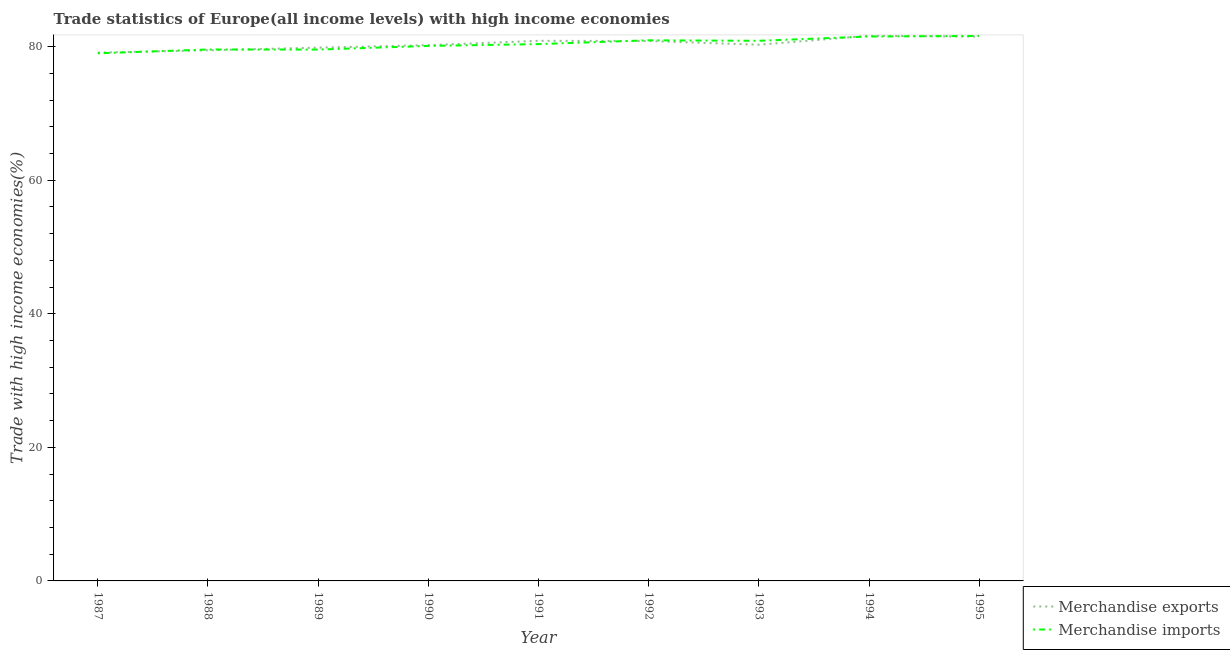How many different coloured lines are there?
Ensure brevity in your answer.  2. Does the line corresponding to merchandise exports intersect with the line corresponding to merchandise imports?
Offer a terse response. Yes. What is the merchandise exports in 1993?
Your response must be concise. 80.3. Across all years, what is the maximum merchandise exports?
Offer a terse response. 81.64. Across all years, what is the minimum merchandise imports?
Your answer should be very brief. 79.01. In which year was the merchandise exports maximum?
Provide a succinct answer. 1994. In which year was the merchandise imports minimum?
Your response must be concise. 1987. What is the total merchandise imports in the graph?
Your answer should be compact. 723.65. What is the difference between the merchandise imports in 1988 and that in 1991?
Your answer should be very brief. -0.81. What is the difference between the merchandise exports in 1992 and the merchandise imports in 1988?
Your answer should be very brief. 1.27. What is the average merchandise imports per year?
Provide a succinct answer. 80.41. In the year 1987, what is the difference between the merchandise exports and merchandise imports?
Provide a short and direct response. 0.1. In how many years, is the merchandise imports greater than 16 %?
Keep it short and to the point. 9. What is the ratio of the merchandise imports in 1988 to that in 1993?
Your answer should be very brief. 0.98. Is the merchandise exports in 1992 less than that in 1993?
Offer a terse response. No. Is the difference between the merchandise exports in 1992 and 1994 greater than the difference between the merchandise imports in 1992 and 1994?
Offer a terse response. No. What is the difference between the highest and the second highest merchandise exports?
Your answer should be very brief. 0.13. What is the difference between the highest and the lowest merchandise exports?
Provide a succinct answer. 2.53. In how many years, is the merchandise exports greater than the average merchandise exports taken over all years?
Your answer should be compact. 4. Is the sum of the merchandise imports in 1988 and 1990 greater than the maximum merchandise exports across all years?
Keep it short and to the point. Yes. Does the merchandise imports monotonically increase over the years?
Offer a terse response. No. How many lines are there?
Offer a very short reply. 2. What is the difference between two consecutive major ticks on the Y-axis?
Provide a short and direct response. 20. Are the values on the major ticks of Y-axis written in scientific E-notation?
Keep it short and to the point. No. Where does the legend appear in the graph?
Your answer should be very brief. Bottom right. What is the title of the graph?
Make the answer very short. Trade statistics of Europe(all income levels) with high income economies. Does "Forest land" appear as one of the legend labels in the graph?
Your answer should be compact. No. What is the label or title of the Y-axis?
Your response must be concise. Trade with high income economies(%). What is the Trade with high income economies(%) of Merchandise exports in 1987?
Your answer should be very brief. 79.11. What is the Trade with high income economies(%) of Merchandise imports in 1987?
Keep it short and to the point. 79.01. What is the Trade with high income economies(%) in Merchandise exports in 1988?
Your response must be concise. 79.46. What is the Trade with high income economies(%) in Merchandise imports in 1988?
Your answer should be very brief. 79.58. What is the Trade with high income economies(%) in Merchandise exports in 1989?
Keep it short and to the point. 79.86. What is the Trade with high income economies(%) in Merchandise imports in 1989?
Ensure brevity in your answer.  79.57. What is the Trade with high income economies(%) of Merchandise exports in 1990?
Your answer should be compact. 80.23. What is the Trade with high income economies(%) in Merchandise imports in 1990?
Your answer should be compact. 80.12. What is the Trade with high income economies(%) in Merchandise exports in 1991?
Your answer should be very brief. 80.88. What is the Trade with high income economies(%) of Merchandise imports in 1991?
Ensure brevity in your answer.  80.39. What is the Trade with high income economies(%) in Merchandise exports in 1992?
Give a very brief answer. 80.85. What is the Trade with high income economies(%) in Merchandise imports in 1992?
Offer a very short reply. 80.96. What is the Trade with high income economies(%) of Merchandise exports in 1993?
Provide a short and direct response. 80.3. What is the Trade with high income economies(%) of Merchandise imports in 1993?
Provide a succinct answer. 80.88. What is the Trade with high income economies(%) in Merchandise exports in 1994?
Provide a short and direct response. 81.64. What is the Trade with high income economies(%) of Merchandise imports in 1994?
Make the answer very short. 81.53. What is the Trade with high income economies(%) of Merchandise exports in 1995?
Your response must be concise. 81.51. What is the Trade with high income economies(%) in Merchandise imports in 1995?
Keep it short and to the point. 81.61. Across all years, what is the maximum Trade with high income economies(%) in Merchandise exports?
Give a very brief answer. 81.64. Across all years, what is the maximum Trade with high income economies(%) in Merchandise imports?
Offer a terse response. 81.61. Across all years, what is the minimum Trade with high income economies(%) of Merchandise exports?
Your answer should be very brief. 79.11. Across all years, what is the minimum Trade with high income economies(%) of Merchandise imports?
Give a very brief answer. 79.01. What is the total Trade with high income economies(%) in Merchandise exports in the graph?
Your answer should be compact. 723.84. What is the total Trade with high income economies(%) of Merchandise imports in the graph?
Give a very brief answer. 723.65. What is the difference between the Trade with high income economies(%) of Merchandise exports in 1987 and that in 1988?
Ensure brevity in your answer.  -0.35. What is the difference between the Trade with high income economies(%) of Merchandise imports in 1987 and that in 1988?
Provide a succinct answer. -0.56. What is the difference between the Trade with high income economies(%) in Merchandise exports in 1987 and that in 1989?
Your answer should be very brief. -0.75. What is the difference between the Trade with high income economies(%) of Merchandise imports in 1987 and that in 1989?
Your response must be concise. -0.56. What is the difference between the Trade with high income economies(%) in Merchandise exports in 1987 and that in 1990?
Your answer should be compact. -1.12. What is the difference between the Trade with high income economies(%) of Merchandise imports in 1987 and that in 1990?
Give a very brief answer. -1.1. What is the difference between the Trade with high income economies(%) of Merchandise exports in 1987 and that in 1991?
Provide a short and direct response. -1.77. What is the difference between the Trade with high income economies(%) of Merchandise imports in 1987 and that in 1991?
Provide a succinct answer. -1.38. What is the difference between the Trade with high income economies(%) of Merchandise exports in 1987 and that in 1992?
Offer a terse response. -1.74. What is the difference between the Trade with high income economies(%) of Merchandise imports in 1987 and that in 1992?
Make the answer very short. -1.95. What is the difference between the Trade with high income economies(%) of Merchandise exports in 1987 and that in 1993?
Provide a short and direct response. -1.18. What is the difference between the Trade with high income economies(%) in Merchandise imports in 1987 and that in 1993?
Make the answer very short. -1.87. What is the difference between the Trade with high income economies(%) of Merchandise exports in 1987 and that in 1994?
Your response must be concise. -2.53. What is the difference between the Trade with high income economies(%) in Merchandise imports in 1987 and that in 1994?
Your response must be concise. -2.51. What is the difference between the Trade with high income economies(%) of Merchandise exports in 1987 and that in 1995?
Your response must be concise. -2.39. What is the difference between the Trade with high income economies(%) of Merchandise imports in 1987 and that in 1995?
Keep it short and to the point. -2.6. What is the difference between the Trade with high income economies(%) in Merchandise exports in 1988 and that in 1989?
Give a very brief answer. -0.39. What is the difference between the Trade with high income economies(%) of Merchandise imports in 1988 and that in 1989?
Provide a succinct answer. 0.01. What is the difference between the Trade with high income economies(%) in Merchandise exports in 1988 and that in 1990?
Your answer should be very brief. -0.77. What is the difference between the Trade with high income economies(%) in Merchandise imports in 1988 and that in 1990?
Offer a terse response. -0.54. What is the difference between the Trade with high income economies(%) in Merchandise exports in 1988 and that in 1991?
Your answer should be very brief. -1.42. What is the difference between the Trade with high income economies(%) in Merchandise imports in 1988 and that in 1991?
Ensure brevity in your answer.  -0.81. What is the difference between the Trade with high income economies(%) of Merchandise exports in 1988 and that in 1992?
Your answer should be very brief. -1.39. What is the difference between the Trade with high income economies(%) of Merchandise imports in 1988 and that in 1992?
Keep it short and to the point. -1.38. What is the difference between the Trade with high income economies(%) of Merchandise exports in 1988 and that in 1993?
Ensure brevity in your answer.  -0.83. What is the difference between the Trade with high income economies(%) of Merchandise imports in 1988 and that in 1993?
Give a very brief answer. -1.31. What is the difference between the Trade with high income economies(%) in Merchandise exports in 1988 and that in 1994?
Provide a short and direct response. -2.18. What is the difference between the Trade with high income economies(%) of Merchandise imports in 1988 and that in 1994?
Ensure brevity in your answer.  -1.95. What is the difference between the Trade with high income economies(%) of Merchandise exports in 1988 and that in 1995?
Your answer should be compact. -2.04. What is the difference between the Trade with high income economies(%) in Merchandise imports in 1988 and that in 1995?
Your answer should be very brief. -2.03. What is the difference between the Trade with high income economies(%) of Merchandise exports in 1989 and that in 1990?
Your answer should be compact. -0.37. What is the difference between the Trade with high income economies(%) in Merchandise imports in 1989 and that in 1990?
Make the answer very short. -0.55. What is the difference between the Trade with high income economies(%) in Merchandise exports in 1989 and that in 1991?
Your answer should be compact. -1.02. What is the difference between the Trade with high income economies(%) in Merchandise imports in 1989 and that in 1991?
Give a very brief answer. -0.82. What is the difference between the Trade with high income economies(%) in Merchandise exports in 1989 and that in 1992?
Your answer should be compact. -0.99. What is the difference between the Trade with high income economies(%) in Merchandise imports in 1989 and that in 1992?
Provide a short and direct response. -1.39. What is the difference between the Trade with high income economies(%) in Merchandise exports in 1989 and that in 1993?
Keep it short and to the point. -0.44. What is the difference between the Trade with high income economies(%) of Merchandise imports in 1989 and that in 1993?
Your answer should be very brief. -1.31. What is the difference between the Trade with high income economies(%) in Merchandise exports in 1989 and that in 1994?
Your answer should be very brief. -1.78. What is the difference between the Trade with high income economies(%) of Merchandise imports in 1989 and that in 1994?
Your response must be concise. -1.96. What is the difference between the Trade with high income economies(%) in Merchandise exports in 1989 and that in 1995?
Provide a short and direct response. -1.65. What is the difference between the Trade with high income economies(%) in Merchandise imports in 1989 and that in 1995?
Your answer should be very brief. -2.04. What is the difference between the Trade with high income economies(%) in Merchandise exports in 1990 and that in 1991?
Make the answer very short. -0.65. What is the difference between the Trade with high income economies(%) in Merchandise imports in 1990 and that in 1991?
Give a very brief answer. -0.27. What is the difference between the Trade with high income economies(%) in Merchandise exports in 1990 and that in 1992?
Make the answer very short. -0.62. What is the difference between the Trade with high income economies(%) in Merchandise imports in 1990 and that in 1992?
Offer a very short reply. -0.84. What is the difference between the Trade with high income economies(%) in Merchandise exports in 1990 and that in 1993?
Give a very brief answer. -0.07. What is the difference between the Trade with high income economies(%) in Merchandise imports in 1990 and that in 1993?
Offer a terse response. -0.77. What is the difference between the Trade with high income economies(%) in Merchandise exports in 1990 and that in 1994?
Provide a succinct answer. -1.41. What is the difference between the Trade with high income economies(%) in Merchandise imports in 1990 and that in 1994?
Your answer should be very brief. -1.41. What is the difference between the Trade with high income economies(%) in Merchandise exports in 1990 and that in 1995?
Your answer should be very brief. -1.28. What is the difference between the Trade with high income economies(%) in Merchandise imports in 1990 and that in 1995?
Ensure brevity in your answer.  -1.5. What is the difference between the Trade with high income economies(%) in Merchandise exports in 1991 and that in 1992?
Make the answer very short. 0.03. What is the difference between the Trade with high income economies(%) in Merchandise imports in 1991 and that in 1992?
Provide a succinct answer. -0.57. What is the difference between the Trade with high income economies(%) of Merchandise exports in 1991 and that in 1993?
Keep it short and to the point. 0.58. What is the difference between the Trade with high income economies(%) in Merchandise imports in 1991 and that in 1993?
Keep it short and to the point. -0.49. What is the difference between the Trade with high income economies(%) of Merchandise exports in 1991 and that in 1994?
Ensure brevity in your answer.  -0.76. What is the difference between the Trade with high income economies(%) in Merchandise imports in 1991 and that in 1994?
Provide a succinct answer. -1.14. What is the difference between the Trade with high income economies(%) of Merchandise exports in 1991 and that in 1995?
Offer a very short reply. -0.63. What is the difference between the Trade with high income economies(%) of Merchandise imports in 1991 and that in 1995?
Provide a succinct answer. -1.22. What is the difference between the Trade with high income economies(%) of Merchandise exports in 1992 and that in 1993?
Ensure brevity in your answer.  0.56. What is the difference between the Trade with high income economies(%) in Merchandise imports in 1992 and that in 1993?
Keep it short and to the point. 0.08. What is the difference between the Trade with high income economies(%) in Merchandise exports in 1992 and that in 1994?
Your response must be concise. -0.79. What is the difference between the Trade with high income economies(%) in Merchandise imports in 1992 and that in 1994?
Keep it short and to the point. -0.57. What is the difference between the Trade with high income economies(%) of Merchandise exports in 1992 and that in 1995?
Provide a short and direct response. -0.65. What is the difference between the Trade with high income economies(%) in Merchandise imports in 1992 and that in 1995?
Provide a succinct answer. -0.65. What is the difference between the Trade with high income economies(%) in Merchandise exports in 1993 and that in 1994?
Your answer should be compact. -1.34. What is the difference between the Trade with high income economies(%) in Merchandise imports in 1993 and that in 1994?
Provide a succinct answer. -0.64. What is the difference between the Trade with high income economies(%) of Merchandise exports in 1993 and that in 1995?
Provide a succinct answer. -1.21. What is the difference between the Trade with high income economies(%) in Merchandise imports in 1993 and that in 1995?
Provide a succinct answer. -0.73. What is the difference between the Trade with high income economies(%) of Merchandise exports in 1994 and that in 1995?
Make the answer very short. 0.13. What is the difference between the Trade with high income economies(%) of Merchandise imports in 1994 and that in 1995?
Offer a terse response. -0.09. What is the difference between the Trade with high income economies(%) in Merchandise exports in 1987 and the Trade with high income economies(%) in Merchandise imports in 1988?
Offer a terse response. -0.47. What is the difference between the Trade with high income economies(%) in Merchandise exports in 1987 and the Trade with high income economies(%) in Merchandise imports in 1989?
Provide a succinct answer. -0.46. What is the difference between the Trade with high income economies(%) in Merchandise exports in 1987 and the Trade with high income economies(%) in Merchandise imports in 1990?
Give a very brief answer. -1. What is the difference between the Trade with high income economies(%) in Merchandise exports in 1987 and the Trade with high income economies(%) in Merchandise imports in 1991?
Your answer should be very brief. -1.28. What is the difference between the Trade with high income economies(%) of Merchandise exports in 1987 and the Trade with high income economies(%) of Merchandise imports in 1992?
Your response must be concise. -1.85. What is the difference between the Trade with high income economies(%) in Merchandise exports in 1987 and the Trade with high income economies(%) in Merchandise imports in 1993?
Your response must be concise. -1.77. What is the difference between the Trade with high income economies(%) in Merchandise exports in 1987 and the Trade with high income economies(%) in Merchandise imports in 1994?
Offer a very short reply. -2.41. What is the difference between the Trade with high income economies(%) in Merchandise exports in 1987 and the Trade with high income economies(%) in Merchandise imports in 1995?
Offer a very short reply. -2.5. What is the difference between the Trade with high income economies(%) of Merchandise exports in 1988 and the Trade with high income economies(%) of Merchandise imports in 1989?
Give a very brief answer. -0.11. What is the difference between the Trade with high income economies(%) of Merchandise exports in 1988 and the Trade with high income economies(%) of Merchandise imports in 1990?
Your answer should be compact. -0.65. What is the difference between the Trade with high income economies(%) in Merchandise exports in 1988 and the Trade with high income economies(%) in Merchandise imports in 1991?
Offer a terse response. -0.93. What is the difference between the Trade with high income economies(%) of Merchandise exports in 1988 and the Trade with high income economies(%) of Merchandise imports in 1992?
Keep it short and to the point. -1.5. What is the difference between the Trade with high income economies(%) in Merchandise exports in 1988 and the Trade with high income economies(%) in Merchandise imports in 1993?
Provide a succinct answer. -1.42. What is the difference between the Trade with high income economies(%) in Merchandise exports in 1988 and the Trade with high income economies(%) in Merchandise imports in 1994?
Ensure brevity in your answer.  -2.06. What is the difference between the Trade with high income economies(%) in Merchandise exports in 1988 and the Trade with high income economies(%) in Merchandise imports in 1995?
Your answer should be very brief. -2.15. What is the difference between the Trade with high income economies(%) of Merchandise exports in 1989 and the Trade with high income economies(%) of Merchandise imports in 1990?
Keep it short and to the point. -0.26. What is the difference between the Trade with high income economies(%) in Merchandise exports in 1989 and the Trade with high income economies(%) in Merchandise imports in 1991?
Provide a short and direct response. -0.53. What is the difference between the Trade with high income economies(%) of Merchandise exports in 1989 and the Trade with high income economies(%) of Merchandise imports in 1992?
Offer a terse response. -1.1. What is the difference between the Trade with high income economies(%) of Merchandise exports in 1989 and the Trade with high income economies(%) of Merchandise imports in 1993?
Your response must be concise. -1.03. What is the difference between the Trade with high income economies(%) of Merchandise exports in 1989 and the Trade with high income economies(%) of Merchandise imports in 1994?
Your answer should be very brief. -1.67. What is the difference between the Trade with high income economies(%) in Merchandise exports in 1989 and the Trade with high income economies(%) in Merchandise imports in 1995?
Provide a succinct answer. -1.75. What is the difference between the Trade with high income economies(%) of Merchandise exports in 1990 and the Trade with high income economies(%) of Merchandise imports in 1991?
Offer a terse response. -0.16. What is the difference between the Trade with high income economies(%) in Merchandise exports in 1990 and the Trade with high income economies(%) in Merchandise imports in 1992?
Your answer should be very brief. -0.73. What is the difference between the Trade with high income economies(%) of Merchandise exports in 1990 and the Trade with high income economies(%) of Merchandise imports in 1993?
Your answer should be very brief. -0.65. What is the difference between the Trade with high income economies(%) of Merchandise exports in 1990 and the Trade with high income economies(%) of Merchandise imports in 1994?
Your answer should be very brief. -1.3. What is the difference between the Trade with high income economies(%) in Merchandise exports in 1990 and the Trade with high income economies(%) in Merchandise imports in 1995?
Provide a short and direct response. -1.38. What is the difference between the Trade with high income economies(%) in Merchandise exports in 1991 and the Trade with high income economies(%) in Merchandise imports in 1992?
Your answer should be very brief. -0.08. What is the difference between the Trade with high income economies(%) in Merchandise exports in 1991 and the Trade with high income economies(%) in Merchandise imports in 1993?
Ensure brevity in your answer.  -0. What is the difference between the Trade with high income economies(%) in Merchandise exports in 1991 and the Trade with high income economies(%) in Merchandise imports in 1994?
Make the answer very short. -0.65. What is the difference between the Trade with high income economies(%) in Merchandise exports in 1991 and the Trade with high income economies(%) in Merchandise imports in 1995?
Offer a very short reply. -0.73. What is the difference between the Trade with high income economies(%) in Merchandise exports in 1992 and the Trade with high income economies(%) in Merchandise imports in 1993?
Your answer should be compact. -0.03. What is the difference between the Trade with high income economies(%) in Merchandise exports in 1992 and the Trade with high income economies(%) in Merchandise imports in 1994?
Provide a succinct answer. -0.67. What is the difference between the Trade with high income economies(%) of Merchandise exports in 1992 and the Trade with high income economies(%) of Merchandise imports in 1995?
Make the answer very short. -0.76. What is the difference between the Trade with high income economies(%) of Merchandise exports in 1993 and the Trade with high income economies(%) of Merchandise imports in 1994?
Provide a short and direct response. -1.23. What is the difference between the Trade with high income economies(%) in Merchandise exports in 1993 and the Trade with high income economies(%) in Merchandise imports in 1995?
Your response must be concise. -1.32. What is the difference between the Trade with high income economies(%) in Merchandise exports in 1994 and the Trade with high income economies(%) in Merchandise imports in 1995?
Keep it short and to the point. 0.03. What is the average Trade with high income economies(%) of Merchandise exports per year?
Your response must be concise. 80.43. What is the average Trade with high income economies(%) in Merchandise imports per year?
Offer a very short reply. 80.41. In the year 1987, what is the difference between the Trade with high income economies(%) of Merchandise exports and Trade with high income economies(%) of Merchandise imports?
Offer a terse response. 0.1. In the year 1988, what is the difference between the Trade with high income economies(%) of Merchandise exports and Trade with high income economies(%) of Merchandise imports?
Provide a succinct answer. -0.12. In the year 1989, what is the difference between the Trade with high income economies(%) of Merchandise exports and Trade with high income economies(%) of Merchandise imports?
Offer a terse response. 0.29. In the year 1990, what is the difference between the Trade with high income economies(%) of Merchandise exports and Trade with high income economies(%) of Merchandise imports?
Provide a short and direct response. 0.11. In the year 1991, what is the difference between the Trade with high income economies(%) of Merchandise exports and Trade with high income economies(%) of Merchandise imports?
Give a very brief answer. 0.49. In the year 1992, what is the difference between the Trade with high income economies(%) in Merchandise exports and Trade with high income economies(%) in Merchandise imports?
Give a very brief answer. -0.11. In the year 1993, what is the difference between the Trade with high income economies(%) of Merchandise exports and Trade with high income economies(%) of Merchandise imports?
Give a very brief answer. -0.59. In the year 1994, what is the difference between the Trade with high income economies(%) of Merchandise exports and Trade with high income economies(%) of Merchandise imports?
Your response must be concise. 0.11. In the year 1995, what is the difference between the Trade with high income economies(%) in Merchandise exports and Trade with high income economies(%) in Merchandise imports?
Provide a short and direct response. -0.11. What is the ratio of the Trade with high income economies(%) of Merchandise exports in 1987 to that in 1988?
Provide a short and direct response. 1. What is the ratio of the Trade with high income economies(%) of Merchandise imports in 1987 to that in 1988?
Provide a short and direct response. 0.99. What is the ratio of the Trade with high income economies(%) in Merchandise exports in 1987 to that in 1989?
Offer a terse response. 0.99. What is the ratio of the Trade with high income economies(%) in Merchandise exports in 1987 to that in 1990?
Offer a very short reply. 0.99. What is the ratio of the Trade with high income economies(%) of Merchandise imports in 1987 to that in 1990?
Keep it short and to the point. 0.99. What is the ratio of the Trade with high income economies(%) of Merchandise exports in 1987 to that in 1991?
Provide a succinct answer. 0.98. What is the ratio of the Trade with high income economies(%) of Merchandise imports in 1987 to that in 1991?
Offer a terse response. 0.98. What is the ratio of the Trade with high income economies(%) in Merchandise exports in 1987 to that in 1992?
Your response must be concise. 0.98. What is the ratio of the Trade with high income economies(%) of Merchandise imports in 1987 to that in 1993?
Offer a terse response. 0.98. What is the ratio of the Trade with high income economies(%) in Merchandise imports in 1987 to that in 1994?
Your answer should be very brief. 0.97. What is the ratio of the Trade with high income economies(%) of Merchandise exports in 1987 to that in 1995?
Offer a terse response. 0.97. What is the ratio of the Trade with high income economies(%) of Merchandise imports in 1987 to that in 1995?
Your response must be concise. 0.97. What is the ratio of the Trade with high income economies(%) in Merchandise imports in 1988 to that in 1989?
Your response must be concise. 1. What is the ratio of the Trade with high income economies(%) in Merchandise imports in 1988 to that in 1990?
Provide a succinct answer. 0.99. What is the ratio of the Trade with high income economies(%) in Merchandise exports in 1988 to that in 1991?
Provide a short and direct response. 0.98. What is the ratio of the Trade with high income economies(%) in Merchandise exports in 1988 to that in 1992?
Keep it short and to the point. 0.98. What is the ratio of the Trade with high income economies(%) of Merchandise imports in 1988 to that in 1992?
Offer a very short reply. 0.98. What is the ratio of the Trade with high income economies(%) of Merchandise exports in 1988 to that in 1993?
Ensure brevity in your answer.  0.99. What is the ratio of the Trade with high income economies(%) in Merchandise imports in 1988 to that in 1993?
Your response must be concise. 0.98. What is the ratio of the Trade with high income economies(%) in Merchandise exports in 1988 to that in 1994?
Make the answer very short. 0.97. What is the ratio of the Trade with high income economies(%) of Merchandise imports in 1988 to that in 1994?
Give a very brief answer. 0.98. What is the ratio of the Trade with high income economies(%) of Merchandise exports in 1988 to that in 1995?
Provide a succinct answer. 0.97. What is the ratio of the Trade with high income economies(%) of Merchandise imports in 1988 to that in 1995?
Offer a terse response. 0.98. What is the ratio of the Trade with high income economies(%) of Merchandise imports in 1989 to that in 1990?
Provide a succinct answer. 0.99. What is the ratio of the Trade with high income economies(%) in Merchandise exports in 1989 to that in 1991?
Your answer should be compact. 0.99. What is the ratio of the Trade with high income economies(%) in Merchandise imports in 1989 to that in 1992?
Make the answer very short. 0.98. What is the ratio of the Trade with high income economies(%) of Merchandise imports in 1989 to that in 1993?
Make the answer very short. 0.98. What is the ratio of the Trade with high income economies(%) of Merchandise exports in 1989 to that in 1994?
Make the answer very short. 0.98. What is the ratio of the Trade with high income economies(%) of Merchandise imports in 1989 to that in 1994?
Offer a terse response. 0.98. What is the ratio of the Trade with high income economies(%) of Merchandise exports in 1989 to that in 1995?
Offer a terse response. 0.98. What is the ratio of the Trade with high income economies(%) in Merchandise imports in 1989 to that in 1995?
Offer a terse response. 0.97. What is the ratio of the Trade with high income economies(%) in Merchandise exports in 1990 to that in 1991?
Your response must be concise. 0.99. What is the ratio of the Trade with high income economies(%) of Merchandise imports in 1990 to that in 1992?
Provide a succinct answer. 0.99. What is the ratio of the Trade with high income economies(%) in Merchandise exports in 1990 to that in 1993?
Offer a very short reply. 1. What is the ratio of the Trade with high income economies(%) of Merchandise exports in 1990 to that in 1994?
Keep it short and to the point. 0.98. What is the ratio of the Trade with high income economies(%) in Merchandise imports in 1990 to that in 1994?
Offer a very short reply. 0.98. What is the ratio of the Trade with high income economies(%) in Merchandise exports in 1990 to that in 1995?
Offer a terse response. 0.98. What is the ratio of the Trade with high income economies(%) of Merchandise imports in 1990 to that in 1995?
Provide a short and direct response. 0.98. What is the ratio of the Trade with high income economies(%) of Merchandise exports in 1991 to that in 1992?
Offer a terse response. 1. What is the ratio of the Trade with high income economies(%) in Merchandise exports in 1991 to that in 1993?
Offer a terse response. 1.01. What is the ratio of the Trade with high income economies(%) of Merchandise imports in 1991 to that in 1993?
Your response must be concise. 0.99. What is the ratio of the Trade with high income economies(%) in Merchandise imports in 1991 to that in 1994?
Your answer should be compact. 0.99. What is the ratio of the Trade with high income economies(%) of Merchandise exports in 1992 to that in 1995?
Keep it short and to the point. 0.99. What is the ratio of the Trade with high income economies(%) of Merchandise exports in 1993 to that in 1994?
Provide a succinct answer. 0.98. What is the ratio of the Trade with high income economies(%) in Merchandise imports in 1993 to that in 1994?
Your answer should be compact. 0.99. What is the ratio of the Trade with high income economies(%) in Merchandise exports in 1993 to that in 1995?
Offer a very short reply. 0.99. What is the ratio of the Trade with high income economies(%) of Merchandise exports in 1994 to that in 1995?
Keep it short and to the point. 1. What is the ratio of the Trade with high income economies(%) in Merchandise imports in 1994 to that in 1995?
Keep it short and to the point. 1. What is the difference between the highest and the second highest Trade with high income economies(%) of Merchandise exports?
Provide a succinct answer. 0.13. What is the difference between the highest and the second highest Trade with high income economies(%) in Merchandise imports?
Your answer should be very brief. 0.09. What is the difference between the highest and the lowest Trade with high income economies(%) of Merchandise exports?
Provide a short and direct response. 2.53. What is the difference between the highest and the lowest Trade with high income economies(%) in Merchandise imports?
Your response must be concise. 2.6. 